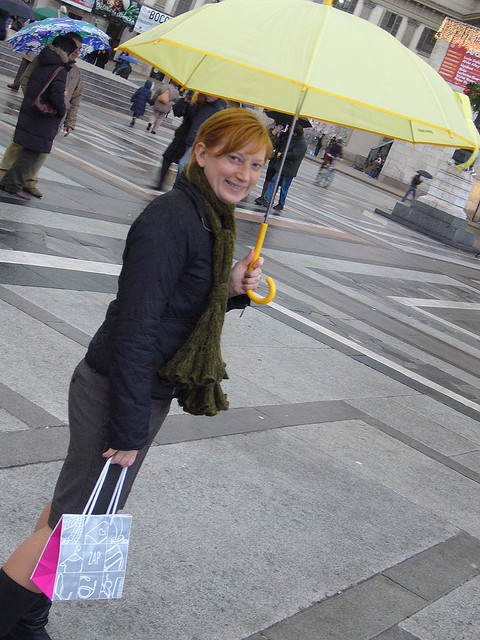Describe the objects in this image and their specific colors. I can see people in navy, black, gray, darkgray, and lavender tones, umbrella in navy, beige, khaki, and darkgray tones, handbag in navy, darkgray, lavender, lightblue, and magenta tones, people in navy, black, and gray tones, and umbrella in navy, darkgray, gray, and teal tones in this image. 